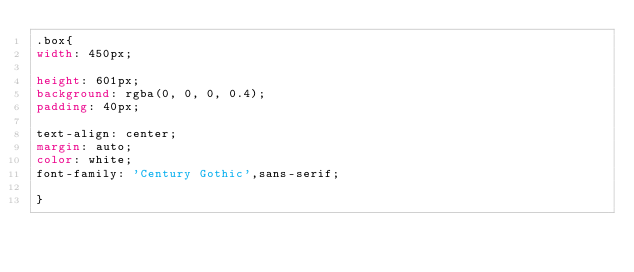<code> <loc_0><loc_0><loc_500><loc_500><_CSS_>.box{
width: 450px;

height: 601px;
background: rgba(0, 0, 0, 0.4);
padding: 40px;

text-align: center;
margin: auto;
color: white;
font-family: 'Century Gothic',sans-serif;

}
</code> 